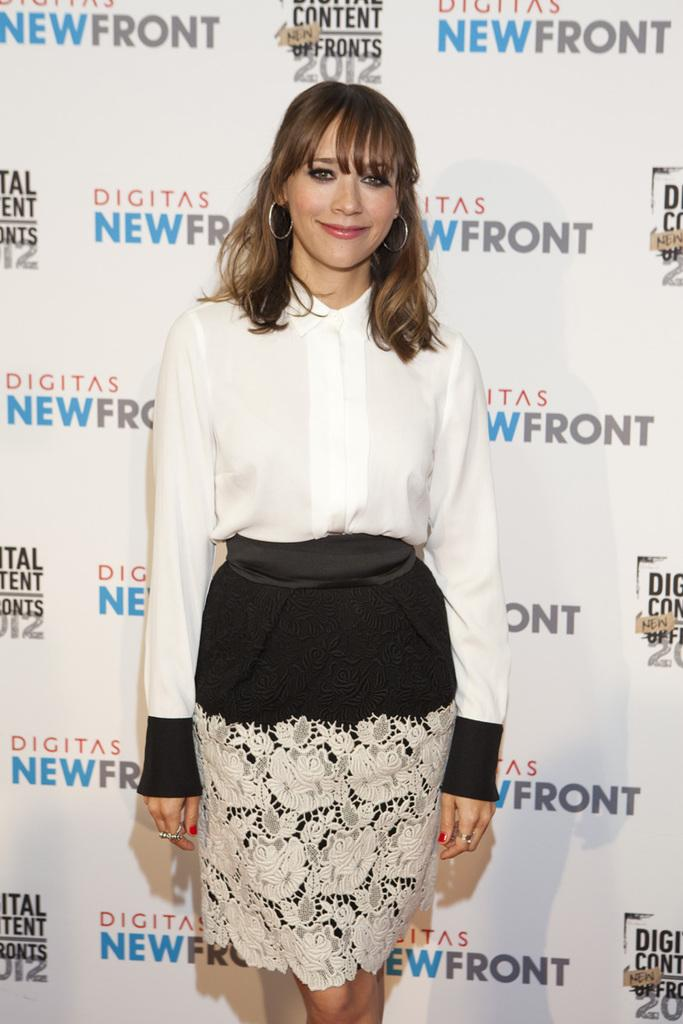Who is present in the image? There is a woman in the image. What is the woman wearing? The woman is wearing a white shirt and black shorts. Where is the woman standing in relation to the banner? The woman is standing near a banner. What is the expression on the woman's face? The woman is smiling. What can be found on the banner? The banner contains quotations and a logo. How many boys are sitting on the coach in the image? There is no coach or boys present in the image; it features a woman standing near a banner. What is the woman thinking about in the image? The image does not provide information about the woman's thoughts, only her facial expression, which is smiling. 